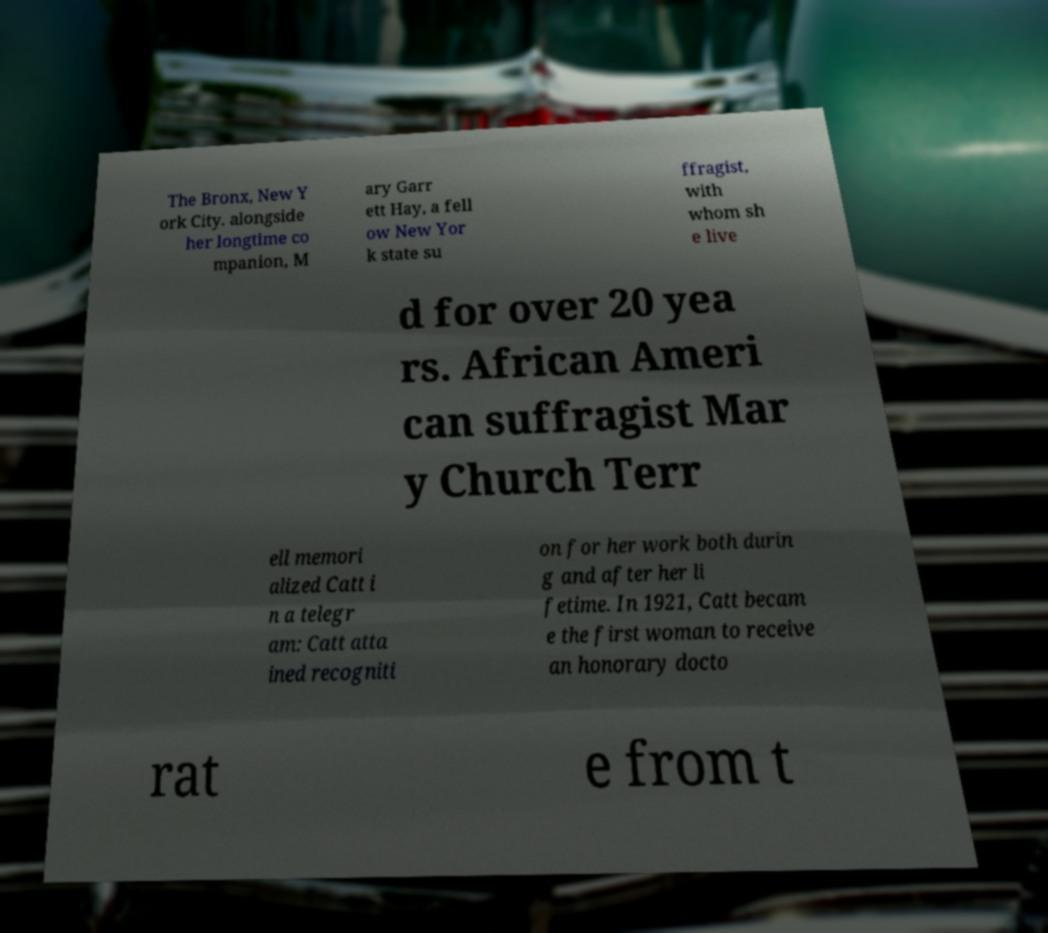For documentation purposes, I need the text within this image transcribed. Could you provide that? The Bronx, New Y ork City. alongside her longtime co mpanion, M ary Garr ett Hay, a fell ow New Yor k state su ffragist, with whom sh e live d for over 20 yea rs. African Ameri can suffragist Mar y Church Terr ell memori alized Catt i n a telegr am: Catt atta ined recogniti on for her work both durin g and after her li fetime. In 1921, Catt becam e the first woman to receive an honorary docto rat e from t 